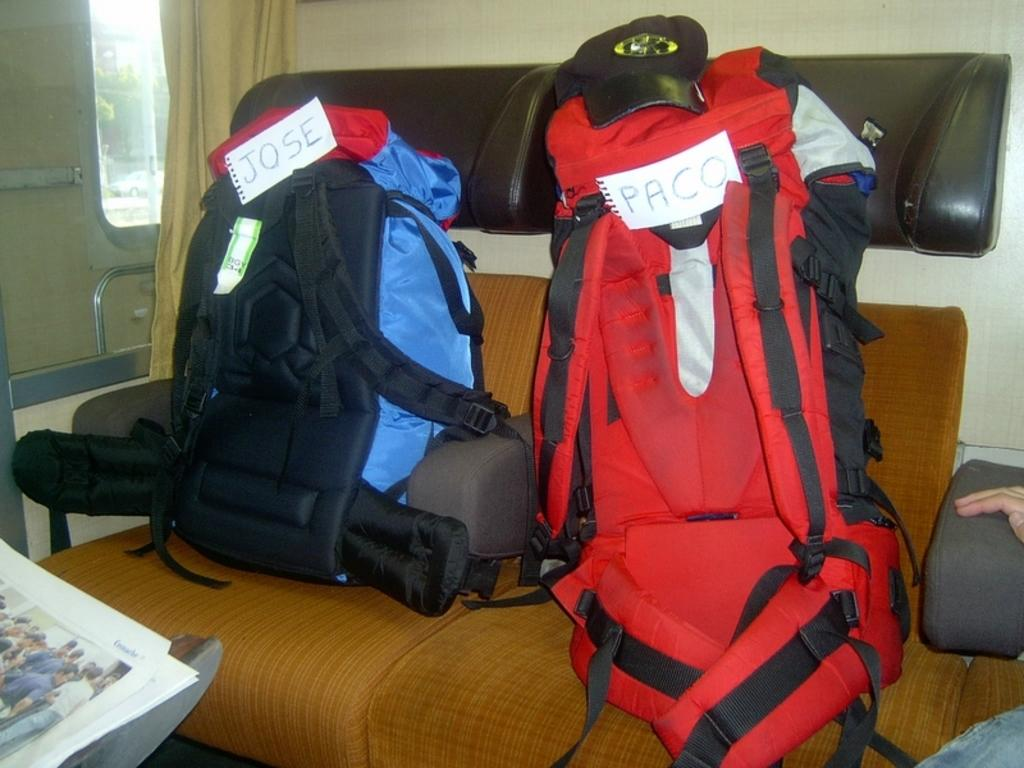<image>
Render a clear and concise summary of the photo. Two backpacks sitting on chairs labeled Jose and Paco 